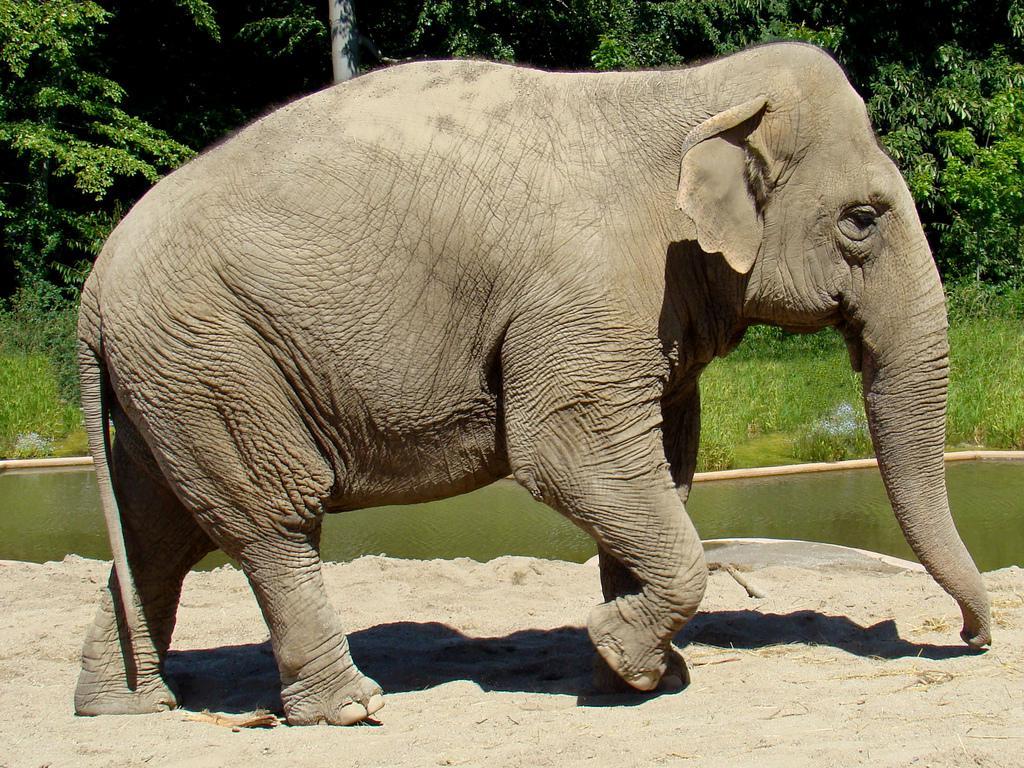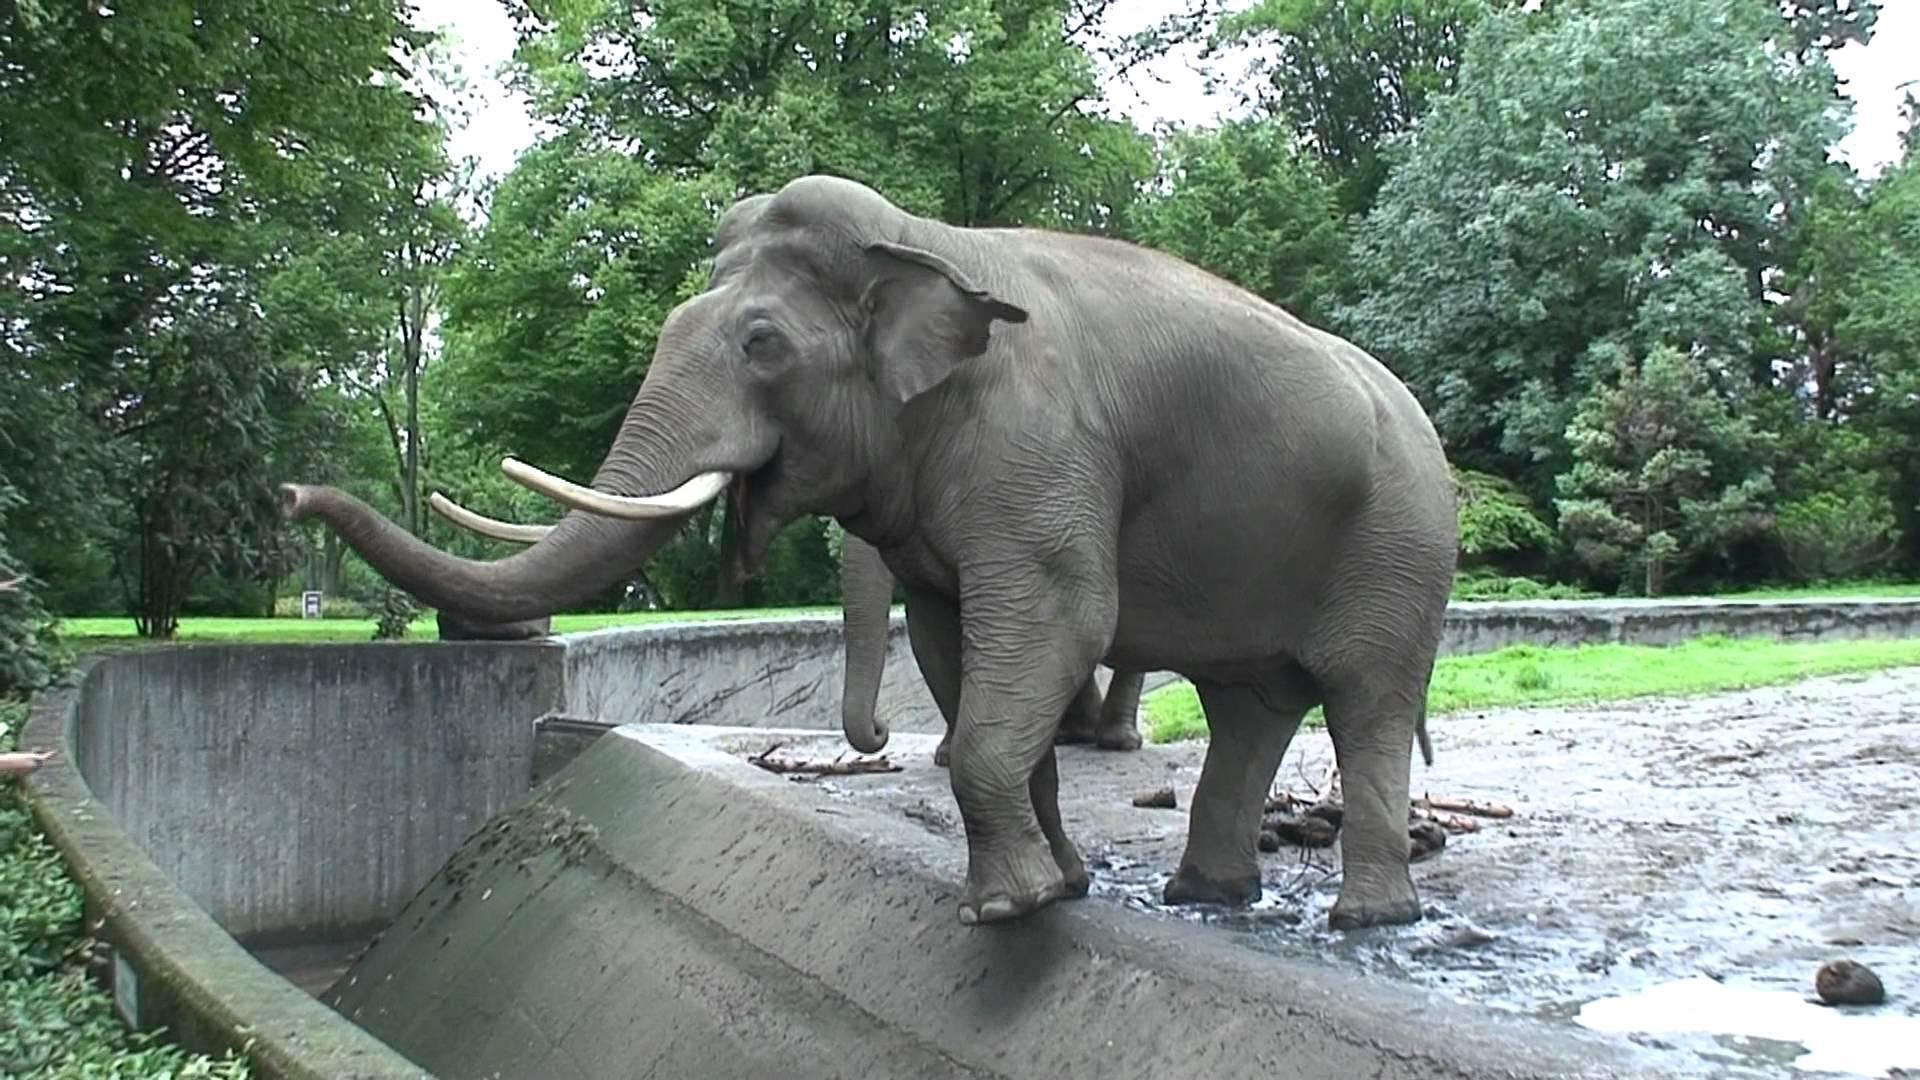The first image is the image on the left, the second image is the image on the right. Considering the images on both sides, is "Both elephants are facing towards the left." valid? Answer yes or no. No. The first image is the image on the left, the second image is the image on the right. Examine the images to the left and right. Is the description "The elephant in the image on the right has its feet on a man made structure." accurate? Answer yes or no. Yes. 